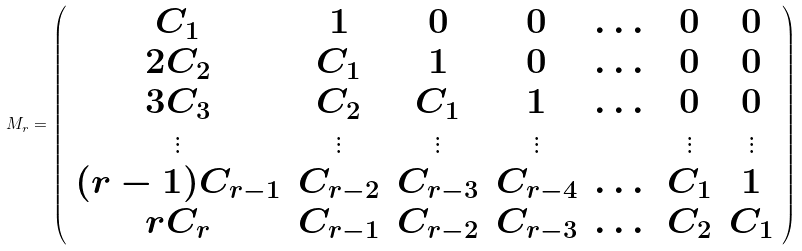<formula> <loc_0><loc_0><loc_500><loc_500>M _ { r } = \left ( \begin{array} { c c c c c c c } C _ { 1 } & 1 & 0 & 0 & \dots & 0 & 0 \\ 2 C _ { 2 } & C _ { 1 } & 1 & 0 & \dots & 0 & 0 \\ 3 C _ { 3 } & C _ { 2 } & C _ { 1 } & 1 & \dots & 0 & 0 \\ \vdots & \vdots & \vdots & \vdots & & \vdots & \vdots \\ ( r - 1 ) C _ { r - 1 } & C _ { r - 2 } & C _ { r - 3 } & C _ { r - 4 } & \dots & C _ { 1 } & 1 \\ r C _ { r } & C _ { r - 1 } & C _ { r - 2 } & C _ { r - 3 } & \dots & C _ { 2 } & C _ { 1 } \end{array} \right )</formula> 